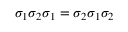<formula> <loc_0><loc_0><loc_500><loc_500>\sigma _ { 1 } \sigma _ { 2 } \sigma _ { 1 } = \sigma _ { 2 } \sigma _ { 1 } \sigma _ { 2 }</formula> 